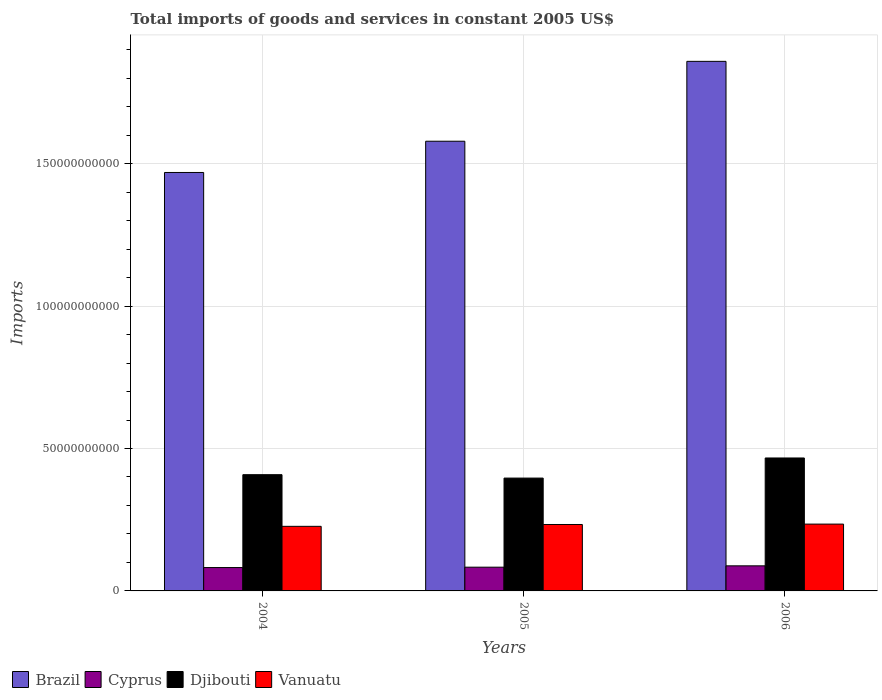How many groups of bars are there?
Give a very brief answer. 3. Are the number of bars on each tick of the X-axis equal?
Your answer should be very brief. Yes. In how many cases, is the number of bars for a given year not equal to the number of legend labels?
Ensure brevity in your answer.  0. What is the total imports of goods and services in Brazil in 2006?
Offer a terse response. 1.86e+11. Across all years, what is the maximum total imports of goods and services in Cyprus?
Offer a terse response. 8.81e+09. Across all years, what is the minimum total imports of goods and services in Brazil?
Your answer should be compact. 1.47e+11. In which year was the total imports of goods and services in Vanuatu maximum?
Offer a terse response. 2006. In which year was the total imports of goods and services in Djibouti minimum?
Make the answer very short. 2005. What is the total total imports of goods and services in Djibouti in the graph?
Give a very brief answer. 1.27e+11. What is the difference between the total imports of goods and services in Cyprus in 2004 and that in 2005?
Offer a terse response. -1.29e+08. What is the difference between the total imports of goods and services in Djibouti in 2005 and the total imports of goods and services in Cyprus in 2004?
Offer a terse response. 3.14e+1. What is the average total imports of goods and services in Djibouti per year?
Your answer should be compact. 4.24e+1. In the year 2004, what is the difference between the total imports of goods and services in Djibouti and total imports of goods and services in Cyprus?
Offer a very short reply. 3.26e+1. What is the ratio of the total imports of goods and services in Djibouti in 2004 to that in 2006?
Your response must be concise. 0.87. Is the difference between the total imports of goods and services in Djibouti in 2004 and 2006 greater than the difference between the total imports of goods and services in Cyprus in 2004 and 2006?
Ensure brevity in your answer.  No. What is the difference between the highest and the second highest total imports of goods and services in Djibouti?
Provide a short and direct response. 5.87e+09. What is the difference between the highest and the lowest total imports of goods and services in Cyprus?
Make the answer very short. 6.04e+08. In how many years, is the total imports of goods and services in Brazil greater than the average total imports of goods and services in Brazil taken over all years?
Offer a terse response. 1. Is the sum of the total imports of goods and services in Djibouti in 2004 and 2005 greater than the maximum total imports of goods and services in Brazil across all years?
Your response must be concise. No. Is it the case that in every year, the sum of the total imports of goods and services in Djibouti and total imports of goods and services in Brazil is greater than the sum of total imports of goods and services in Cyprus and total imports of goods and services in Vanuatu?
Provide a short and direct response. Yes. What does the 4th bar from the left in 2004 represents?
Provide a short and direct response. Vanuatu. What does the 4th bar from the right in 2004 represents?
Make the answer very short. Brazil. Is it the case that in every year, the sum of the total imports of goods and services in Djibouti and total imports of goods and services in Vanuatu is greater than the total imports of goods and services in Cyprus?
Give a very brief answer. Yes. Are all the bars in the graph horizontal?
Ensure brevity in your answer.  No. How many years are there in the graph?
Offer a terse response. 3. Are the values on the major ticks of Y-axis written in scientific E-notation?
Provide a short and direct response. No. Does the graph contain grids?
Provide a succinct answer. Yes. How many legend labels are there?
Your answer should be very brief. 4. How are the legend labels stacked?
Provide a short and direct response. Horizontal. What is the title of the graph?
Give a very brief answer. Total imports of goods and services in constant 2005 US$. What is the label or title of the Y-axis?
Offer a very short reply. Imports. What is the Imports in Brazil in 2004?
Give a very brief answer. 1.47e+11. What is the Imports in Cyprus in 2004?
Ensure brevity in your answer.  8.21e+09. What is the Imports in Djibouti in 2004?
Provide a short and direct response. 4.08e+1. What is the Imports in Vanuatu in 2004?
Ensure brevity in your answer.  2.27e+1. What is the Imports of Brazil in 2005?
Make the answer very short. 1.58e+11. What is the Imports in Cyprus in 2005?
Provide a short and direct response. 8.33e+09. What is the Imports of Djibouti in 2005?
Your response must be concise. 3.96e+1. What is the Imports of Vanuatu in 2005?
Keep it short and to the point. 2.33e+1. What is the Imports in Brazil in 2006?
Make the answer very short. 1.86e+11. What is the Imports of Cyprus in 2006?
Provide a short and direct response. 8.81e+09. What is the Imports of Djibouti in 2006?
Give a very brief answer. 4.67e+1. What is the Imports of Vanuatu in 2006?
Offer a very short reply. 2.35e+1. Across all years, what is the maximum Imports of Brazil?
Provide a short and direct response. 1.86e+11. Across all years, what is the maximum Imports in Cyprus?
Give a very brief answer. 8.81e+09. Across all years, what is the maximum Imports of Djibouti?
Provide a short and direct response. 4.67e+1. Across all years, what is the maximum Imports of Vanuatu?
Ensure brevity in your answer.  2.35e+1. Across all years, what is the minimum Imports of Brazil?
Your answer should be very brief. 1.47e+11. Across all years, what is the minimum Imports in Cyprus?
Provide a succinct answer. 8.21e+09. Across all years, what is the minimum Imports of Djibouti?
Your response must be concise. 3.96e+1. Across all years, what is the minimum Imports in Vanuatu?
Provide a succinct answer. 2.27e+1. What is the total Imports of Brazil in the graph?
Give a very brief answer. 4.91e+11. What is the total Imports in Cyprus in the graph?
Your response must be concise. 2.53e+1. What is the total Imports in Djibouti in the graph?
Offer a terse response. 1.27e+11. What is the total Imports of Vanuatu in the graph?
Keep it short and to the point. 6.95e+1. What is the difference between the Imports of Brazil in 2004 and that in 2005?
Your response must be concise. -1.10e+1. What is the difference between the Imports of Cyprus in 2004 and that in 2005?
Give a very brief answer. -1.29e+08. What is the difference between the Imports of Djibouti in 2004 and that in 2005?
Give a very brief answer. 1.19e+09. What is the difference between the Imports of Vanuatu in 2004 and that in 2005?
Ensure brevity in your answer.  -6.50e+08. What is the difference between the Imports of Brazil in 2004 and that in 2006?
Provide a short and direct response. -3.90e+1. What is the difference between the Imports of Cyprus in 2004 and that in 2006?
Offer a very short reply. -6.04e+08. What is the difference between the Imports of Djibouti in 2004 and that in 2006?
Make the answer very short. -5.87e+09. What is the difference between the Imports in Vanuatu in 2004 and that in 2006?
Your response must be concise. -7.89e+08. What is the difference between the Imports of Brazil in 2005 and that in 2006?
Offer a terse response. -2.80e+1. What is the difference between the Imports of Cyprus in 2005 and that in 2006?
Your answer should be very brief. -4.75e+08. What is the difference between the Imports in Djibouti in 2005 and that in 2006?
Offer a terse response. -7.06e+09. What is the difference between the Imports in Vanuatu in 2005 and that in 2006?
Offer a very short reply. -1.39e+08. What is the difference between the Imports of Brazil in 2004 and the Imports of Cyprus in 2005?
Provide a short and direct response. 1.39e+11. What is the difference between the Imports in Brazil in 2004 and the Imports in Djibouti in 2005?
Ensure brevity in your answer.  1.07e+11. What is the difference between the Imports of Brazil in 2004 and the Imports of Vanuatu in 2005?
Make the answer very short. 1.24e+11. What is the difference between the Imports of Cyprus in 2004 and the Imports of Djibouti in 2005?
Offer a very short reply. -3.14e+1. What is the difference between the Imports in Cyprus in 2004 and the Imports in Vanuatu in 2005?
Your response must be concise. -1.51e+1. What is the difference between the Imports in Djibouti in 2004 and the Imports in Vanuatu in 2005?
Make the answer very short. 1.75e+1. What is the difference between the Imports of Brazil in 2004 and the Imports of Cyprus in 2006?
Ensure brevity in your answer.  1.38e+11. What is the difference between the Imports of Brazil in 2004 and the Imports of Djibouti in 2006?
Provide a succinct answer. 1.00e+11. What is the difference between the Imports of Brazil in 2004 and the Imports of Vanuatu in 2006?
Provide a short and direct response. 1.23e+11. What is the difference between the Imports of Cyprus in 2004 and the Imports of Djibouti in 2006?
Offer a terse response. -3.85e+1. What is the difference between the Imports in Cyprus in 2004 and the Imports in Vanuatu in 2006?
Provide a short and direct response. -1.53e+1. What is the difference between the Imports in Djibouti in 2004 and the Imports in Vanuatu in 2006?
Keep it short and to the point. 1.73e+1. What is the difference between the Imports of Brazil in 2005 and the Imports of Cyprus in 2006?
Provide a succinct answer. 1.49e+11. What is the difference between the Imports in Brazil in 2005 and the Imports in Djibouti in 2006?
Your answer should be very brief. 1.11e+11. What is the difference between the Imports in Brazil in 2005 and the Imports in Vanuatu in 2006?
Ensure brevity in your answer.  1.34e+11. What is the difference between the Imports of Cyprus in 2005 and the Imports of Djibouti in 2006?
Ensure brevity in your answer.  -3.83e+1. What is the difference between the Imports in Cyprus in 2005 and the Imports in Vanuatu in 2006?
Offer a very short reply. -1.51e+1. What is the difference between the Imports in Djibouti in 2005 and the Imports in Vanuatu in 2006?
Offer a terse response. 1.62e+1. What is the average Imports in Brazil per year?
Your answer should be very brief. 1.64e+11. What is the average Imports in Cyprus per year?
Provide a succinct answer. 8.45e+09. What is the average Imports in Djibouti per year?
Make the answer very short. 4.24e+1. What is the average Imports of Vanuatu per year?
Offer a very short reply. 2.32e+1. In the year 2004, what is the difference between the Imports of Brazil and Imports of Cyprus?
Give a very brief answer. 1.39e+11. In the year 2004, what is the difference between the Imports of Brazil and Imports of Djibouti?
Ensure brevity in your answer.  1.06e+11. In the year 2004, what is the difference between the Imports in Brazil and Imports in Vanuatu?
Provide a succinct answer. 1.24e+11. In the year 2004, what is the difference between the Imports in Cyprus and Imports in Djibouti?
Your answer should be very brief. -3.26e+1. In the year 2004, what is the difference between the Imports of Cyprus and Imports of Vanuatu?
Give a very brief answer. -1.45e+1. In the year 2004, what is the difference between the Imports in Djibouti and Imports in Vanuatu?
Provide a succinct answer. 1.81e+1. In the year 2005, what is the difference between the Imports in Brazil and Imports in Cyprus?
Provide a succinct answer. 1.50e+11. In the year 2005, what is the difference between the Imports of Brazil and Imports of Djibouti?
Your answer should be very brief. 1.18e+11. In the year 2005, what is the difference between the Imports of Brazil and Imports of Vanuatu?
Offer a terse response. 1.35e+11. In the year 2005, what is the difference between the Imports of Cyprus and Imports of Djibouti?
Your response must be concise. -3.13e+1. In the year 2005, what is the difference between the Imports in Cyprus and Imports in Vanuatu?
Give a very brief answer. -1.50e+1. In the year 2005, what is the difference between the Imports of Djibouti and Imports of Vanuatu?
Offer a terse response. 1.63e+1. In the year 2006, what is the difference between the Imports in Brazil and Imports in Cyprus?
Your response must be concise. 1.77e+11. In the year 2006, what is the difference between the Imports of Brazil and Imports of Djibouti?
Offer a terse response. 1.39e+11. In the year 2006, what is the difference between the Imports of Brazil and Imports of Vanuatu?
Keep it short and to the point. 1.62e+11. In the year 2006, what is the difference between the Imports of Cyprus and Imports of Djibouti?
Keep it short and to the point. -3.79e+1. In the year 2006, what is the difference between the Imports in Cyprus and Imports in Vanuatu?
Give a very brief answer. -1.47e+1. In the year 2006, what is the difference between the Imports of Djibouti and Imports of Vanuatu?
Offer a terse response. 2.32e+1. What is the ratio of the Imports in Brazil in 2004 to that in 2005?
Provide a succinct answer. 0.93. What is the ratio of the Imports of Cyprus in 2004 to that in 2005?
Your answer should be very brief. 0.98. What is the ratio of the Imports of Djibouti in 2004 to that in 2005?
Keep it short and to the point. 1.03. What is the ratio of the Imports of Vanuatu in 2004 to that in 2005?
Ensure brevity in your answer.  0.97. What is the ratio of the Imports in Brazil in 2004 to that in 2006?
Your answer should be very brief. 0.79. What is the ratio of the Imports of Cyprus in 2004 to that in 2006?
Provide a short and direct response. 0.93. What is the ratio of the Imports in Djibouti in 2004 to that in 2006?
Your answer should be very brief. 0.87. What is the ratio of the Imports in Vanuatu in 2004 to that in 2006?
Provide a succinct answer. 0.97. What is the ratio of the Imports of Brazil in 2005 to that in 2006?
Offer a very short reply. 0.85. What is the ratio of the Imports in Cyprus in 2005 to that in 2006?
Your answer should be very brief. 0.95. What is the ratio of the Imports of Djibouti in 2005 to that in 2006?
Keep it short and to the point. 0.85. What is the ratio of the Imports of Vanuatu in 2005 to that in 2006?
Your answer should be very brief. 0.99. What is the difference between the highest and the second highest Imports of Brazil?
Ensure brevity in your answer.  2.80e+1. What is the difference between the highest and the second highest Imports in Cyprus?
Your response must be concise. 4.75e+08. What is the difference between the highest and the second highest Imports of Djibouti?
Offer a terse response. 5.87e+09. What is the difference between the highest and the second highest Imports in Vanuatu?
Ensure brevity in your answer.  1.39e+08. What is the difference between the highest and the lowest Imports of Brazil?
Your response must be concise. 3.90e+1. What is the difference between the highest and the lowest Imports of Cyprus?
Offer a very short reply. 6.04e+08. What is the difference between the highest and the lowest Imports in Djibouti?
Provide a short and direct response. 7.06e+09. What is the difference between the highest and the lowest Imports in Vanuatu?
Your answer should be compact. 7.89e+08. 